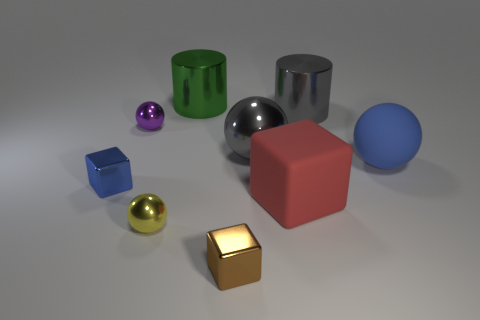Subtract all cylinders. How many objects are left? 7 Subtract 0 purple blocks. How many objects are left? 9 Subtract all big green cylinders. Subtract all green metallic things. How many objects are left? 7 Add 8 tiny brown metallic objects. How many tiny brown metallic objects are left? 9 Add 2 brown metal cylinders. How many brown metal cylinders exist? 2 